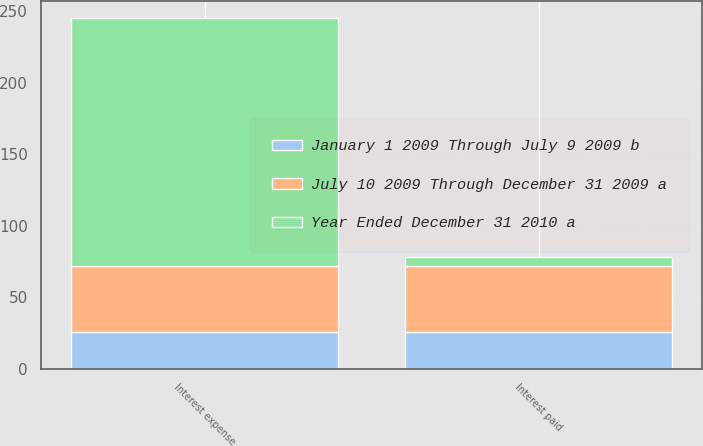Convert chart to OTSL. <chart><loc_0><loc_0><loc_500><loc_500><stacked_bar_chart><ecel><fcel>Interest expense<fcel>Interest paid<nl><fcel>January 1 2009 Through July 9 2009 b<fcel>26<fcel>26<nl><fcel>July 10 2009 Through December 31 2009 a<fcel>46<fcel>46<nl><fcel>Year Ended December 31 2010 a<fcel>173<fcel>6<nl></chart> 